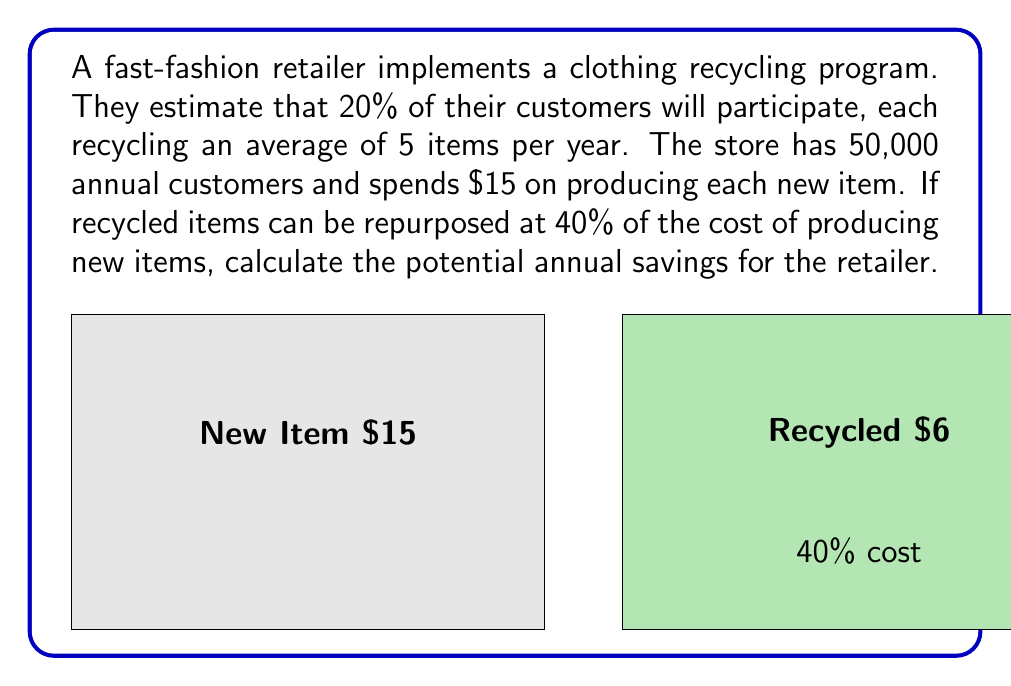Show me your answer to this math problem. Let's break this problem down step-by-step:

1) First, calculate the number of customers participating in the recycling program:
   $20\% \text{ of } 50,000 = 0.2 \times 50,000 = 10,000 \text{ customers}$

2) Calculate the total number of items recycled annually:
   $10,000 \text{ customers} \times 5 \text{ items per customer} = 50,000 \text{ items}$

3) Calculate the cost of producing 50,000 new items:
   $50,000 \text{ items} \times \$15 \text{ per item} = \$750,000$

4) Calculate the cost of repurposing 50,000 recycled items:
   $40\% \text{ of } \$15 = 0.4 \times \$15 = \$6 \text{ per item}$
   $50,000 \text{ items} \times \$6 \text{ per item} = \$300,000$

5) Calculate the savings by subtracting the cost of repurposing from the cost of producing new items:
   $\$750,000 - \$300,000 = \$450,000$

Therefore, the potential annual savings for the retailer is $450,000.
Answer: $450,000 